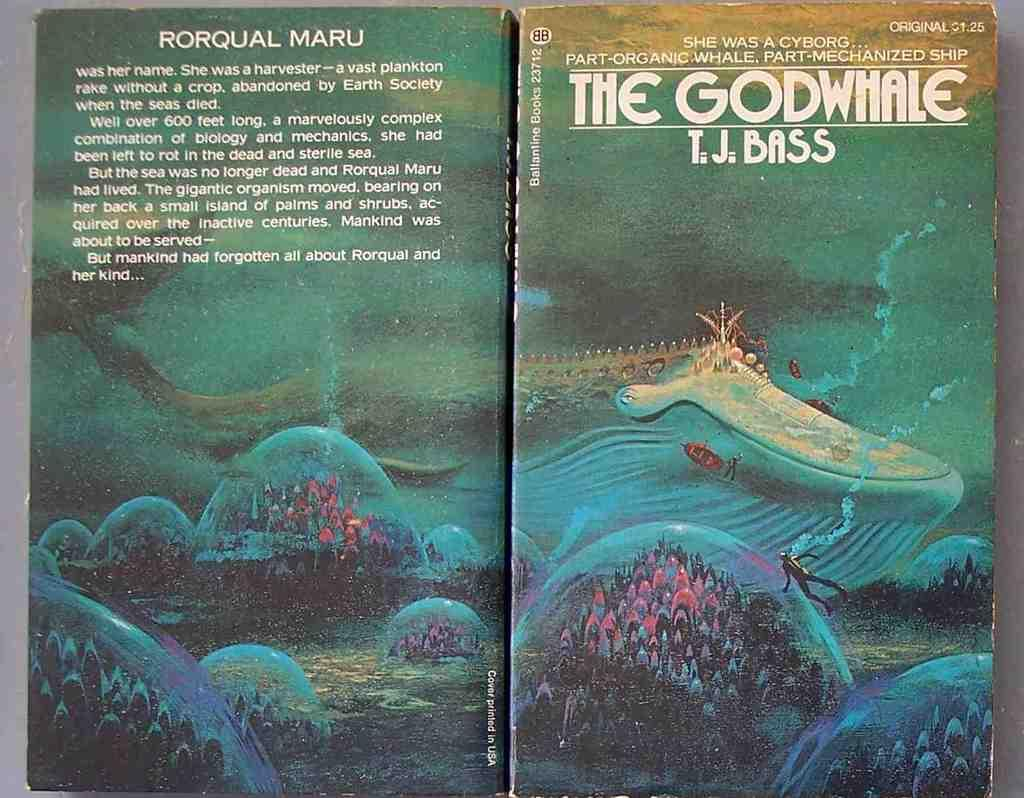<image>
Offer a succinct explanation of the picture presented. Both the front and back of a book titled The Godwhale are visible. 